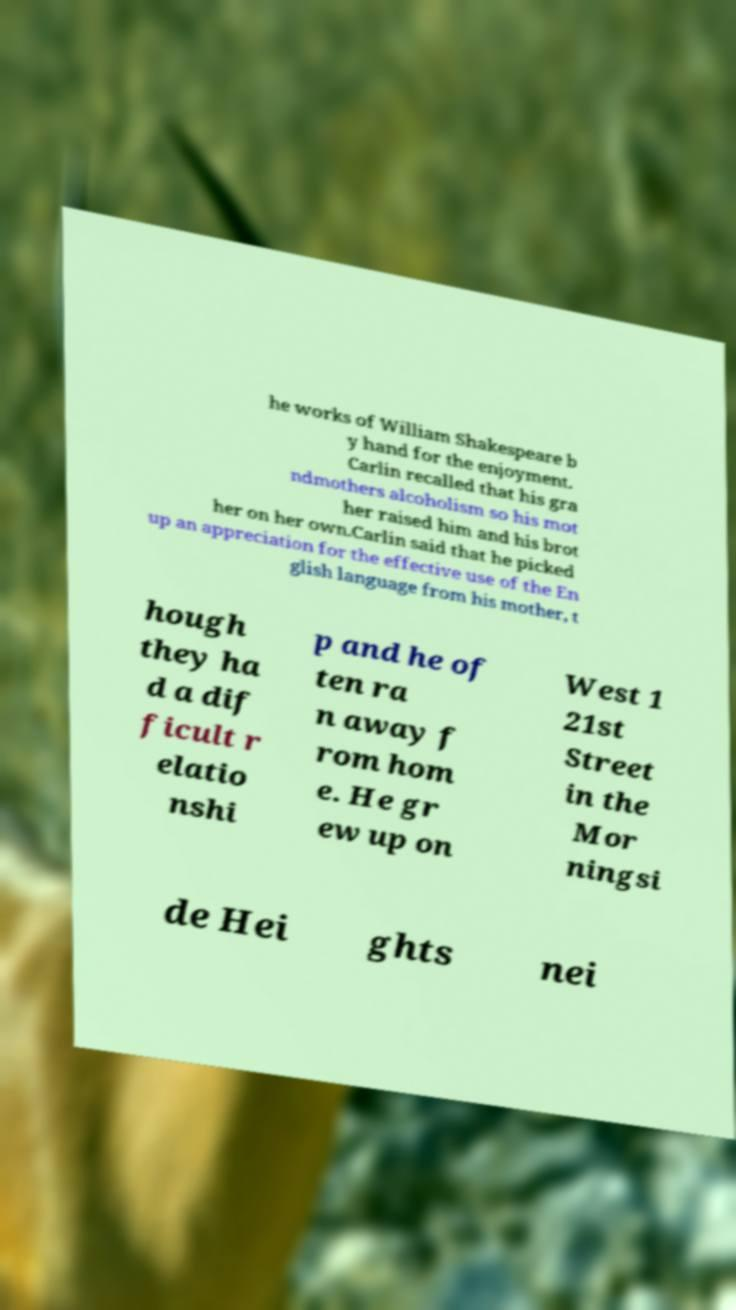Can you read and provide the text displayed in the image?This photo seems to have some interesting text. Can you extract and type it out for me? he works of William Shakespeare b y hand for the enjoyment. Carlin recalled that his gra ndmothers alcoholism so his mot her raised him and his brot her on her own.Carlin said that he picked up an appreciation for the effective use of the En glish language from his mother, t hough they ha d a dif ficult r elatio nshi p and he of ten ra n away f rom hom e. He gr ew up on West 1 21st Street in the Mor ningsi de Hei ghts nei 